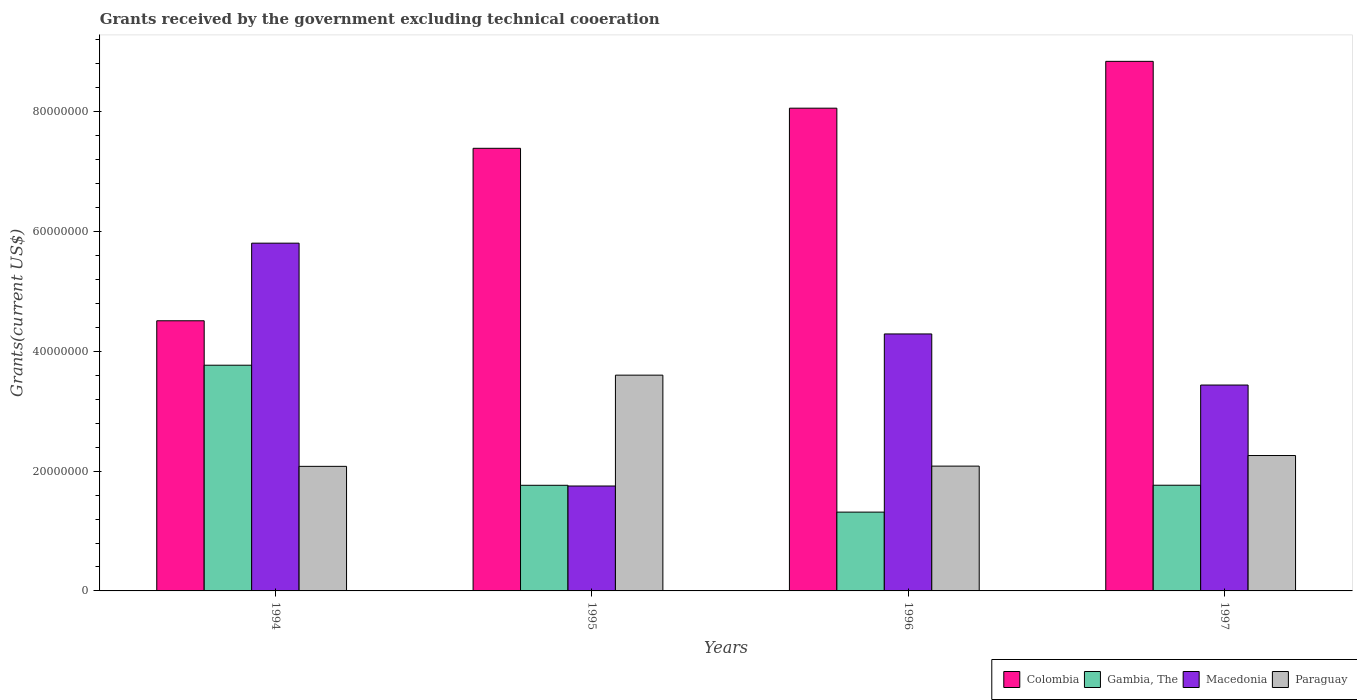How many groups of bars are there?
Give a very brief answer. 4. How many bars are there on the 2nd tick from the left?
Your answer should be very brief. 4. What is the label of the 2nd group of bars from the left?
Keep it short and to the point. 1995. In how many cases, is the number of bars for a given year not equal to the number of legend labels?
Your answer should be compact. 0. What is the total grants received by the government in Paraguay in 1994?
Offer a terse response. 2.08e+07. Across all years, what is the maximum total grants received by the government in Gambia, The?
Keep it short and to the point. 3.77e+07. Across all years, what is the minimum total grants received by the government in Gambia, The?
Give a very brief answer. 1.32e+07. In which year was the total grants received by the government in Colombia maximum?
Keep it short and to the point. 1997. What is the total total grants received by the government in Paraguay in the graph?
Offer a terse response. 1.00e+08. What is the difference between the total grants received by the government in Colombia in 1994 and that in 1996?
Your answer should be very brief. -3.55e+07. What is the difference between the total grants received by the government in Gambia, The in 1994 and the total grants received by the government in Paraguay in 1995?
Ensure brevity in your answer.  1.66e+06. What is the average total grants received by the government in Macedonia per year?
Give a very brief answer. 3.82e+07. In the year 1994, what is the difference between the total grants received by the government in Colombia and total grants received by the government in Macedonia?
Offer a very short reply. -1.30e+07. What is the ratio of the total grants received by the government in Paraguay in 1995 to that in 1996?
Keep it short and to the point. 1.73. Is the difference between the total grants received by the government in Colombia in 1995 and 1996 greater than the difference between the total grants received by the government in Macedonia in 1995 and 1996?
Give a very brief answer. Yes. What is the difference between the highest and the second highest total grants received by the government in Paraguay?
Your response must be concise. 1.34e+07. What is the difference between the highest and the lowest total grants received by the government in Colombia?
Your answer should be compact. 4.33e+07. In how many years, is the total grants received by the government in Colombia greater than the average total grants received by the government in Colombia taken over all years?
Offer a terse response. 3. What does the 3rd bar from the left in 1994 represents?
Your answer should be compact. Macedonia. What does the 4th bar from the right in 1995 represents?
Ensure brevity in your answer.  Colombia. How many years are there in the graph?
Ensure brevity in your answer.  4. Does the graph contain any zero values?
Provide a short and direct response. No. Where does the legend appear in the graph?
Make the answer very short. Bottom right. How many legend labels are there?
Offer a very short reply. 4. What is the title of the graph?
Your answer should be compact. Grants received by the government excluding technical cooeration. Does "Middle income" appear as one of the legend labels in the graph?
Keep it short and to the point. No. What is the label or title of the Y-axis?
Offer a terse response. Grants(current US$). What is the Grants(current US$) of Colombia in 1994?
Provide a short and direct response. 4.51e+07. What is the Grants(current US$) of Gambia, The in 1994?
Your answer should be very brief. 3.77e+07. What is the Grants(current US$) of Macedonia in 1994?
Offer a terse response. 5.81e+07. What is the Grants(current US$) in Paraguay in 1994?
Make the answer very short. 2.08e+07. What is the Grants(current US$) in Colombia in 1995?
Offer a very short reply. 7.39e+07. What is the Grants(current US$) of Gambia, The in 1995?
Ensure brevity in your answer.  1.76e+07. What is the Grants(current US$) in Macedonia in 1995?
Make the answer very short. 1.75e+07. What is the Grants(current US$) in Paraguay in 1995?
Give a very brief answer. 3.60e+07. What is the Grants(current US$) of Colombia in 1996?
Offer a terse response. 8.06e+07. What is the Grants(current US$) in Gambia, The in 1996?
Provide a succinct answer. 1.32e+07. What is the Grants(current US$) in Macedonia in 1996?
Offer a terse response. 4.29e+07. What is the Grants(current US$) in Paraguay in 1996?
Ensure brevity in your answer.  2.08e+07. What is the Grants(current US$) in Colombia in 1997?
Ensure brevity in your answer.  8.84e+07. What is the Grants(current US$) of Gambia, The in 1997?
Offer a very short reply. 1.76e+07. What is the Grants(current US$) of Macedonia in 1997?
Keep it short and to the point. 3.44e+07. What is the Grants(current US$) in Paraguay in 1997?
Keep it short and to the point. 2.26e+07. Across all years, what is the maximum Grants(current US$) of Colombia?
Give a very brief answer. 8.84e+07. Across all years, what is the maximum Grants(current US$) in Gambia, The?
Your answer should be very brief. 3.77e+07. Across all years, what is the maximum Grants(current US$) in Macedonia?
Offer a very short reply. 5.81e+07. Across all years, what is the maximum Grants(current US$) of Paraguay?
Provide a succinct answer. 3.60e+07. Across all years, what is the minimum Grants(current US$) of Colombia?
Provide a short and direct response. 4.51e+07. Across all years, what is the minimum Grants(current US$) of Gambia, The?
Make the answer very short. 1.32e+07. Across all years, what is the minimum Grants(current US$) of Macedonia?
Provide a succinct answer. 1.75e+07. Across all years, what is the minimum Grants(current US$) of Paraguay?
Make the answer very short. 2.08e+07. What is the total Grants(current US$) of Colombia in the graph?
Make the answer very short. 2.88e+08. What is the total Grants(current US$) in Gambia, The in the graph?
Offer a terse response. 8.61e+07. What is the total Grants(current US$) of Macedonia in the graph?
Give a very brief answer. 1.53e+08. What is the total Grants(current US$) of Paraguay in the graph?
Provide a succinct answer. 1.00e+08. What is the difference between the Grants(current US$) of Colombia in 1994 and that in 1995?
Provide a short and direct response. -2.88e+07. What is the difference between the Grants(current US$) in Gambia, The in 1994 and that in 1995?
Ensure brevity in your answer.  2.00e+07. What is the difference between the Grants(current US$) in Macedonia in 1994 and that in 1995?
Provide a short and direct response. 4.06e+07. What is the difference between the Grants(current US$) in Paraguay in 1994 and that in 1995?
Provide a succinct answer. -1.52e+07. What is the difference between the Grants(current US$) of Colombia in 1994 and that in 1996?
Your answer should be very brief. -3.55e+07. What is the difference between the Grants(current US$) in Gambia, The in 1994 and that in 1996?
Keep it short and to the point. 2.45e+07. What is the difference between the Grants(current US$) of Macedonia in 1994 and that in 1996?
Make the answer very short. 1.52e+07. What is the difference between the Grants(current US$) in Paraguay in 1994 and that in 1996?
Ensure brevity in your answer.  -4.00e+04. What is the difference between the Grants(current US$) of Colombia in 1994 and that in 1997?
Give a very brief answer. -4.33e+07. What is the difference between the Grants(current US$) in Gambia, The in 1994 and that in 1997?
Your answer should be very brief. 2.00e+07. What is the difference between the Grants(current US$) of Macedonia in 1994 and that in 1997?
Provide a succinct answer. 2.37e+07. What is the difference between the Grants(current US$) in Paraguay in 1994 and that in 1997?
Your answer should be very brief. -1.81e+06. What is the difference between the Grants(current US$) in Colombia in 1995 and that in 1996?
Keep it short and to the point. -6.70e+06. What is the difference between the Grants(current US$) in Gambia, The in 1995 and that in 1996?
Your answer should be compact. 4.48e+06. What is the difference between the Grants(current US$) of Macedonia in 1995 and that in 1996?
Your answer should be very brief. -2.54e+07. What is the difference between the Grants(current US$) in Paraguay in 1995 and that in 1996?
Offer a terse response. 1.52e+07. What is the difference between the Grants(current US$) in Colombia in 1995 and that in 1997?
Offer a very short reply. -1.45e+07. What is the difference between the Grants(current US$) in Macedonia in 1995 and that in 1997?
Give a very brief answer. -1.69e+07. What is the difference between the Grants(current US$) in Paraguay in 1995 and that in 1997?
Your response must be concise. 1.34e+07. What is the difference between the Grants(current US$) of Colombia in 1996 and that in 1997?
Make the answer very short. -7.82e+06. What is the difference between the Grants(current US$) of Gambia, The in 1996 and that in 1997?
Offer a very short reply. -4.49e+06. What is the difference between the Grants(current US$) of Macedonia in 1996 and that in 1997?
Keep it short and to the point. 8.53e+06. What is the difference between the Grants(current US$) in Paraguay in 1996 and that in 1997?
Your response must be concise. -1.77e+06. What is the difference between the Grants(current US$) in Colombia in 1994 and the Grants(current US$) in Gambia, The in 1995?
Offer a very short reply. 2.75e+07. What is the difference between the Grants(current US$) of Colombia in 1994 and the Grants(current US$) of Macedonia in 1995?
Your response must be concise. 2.76e+07. What is the difference between the Grants(current US$) of Colombia in 1994 and the Grants(current US$) of Paraguay in 1995?
Provide a succinct answer. 9.08e+06. What is the difference between the Grants(current US$) of Gambia, The in 1994 and the Grants(current US$) of Macedonia in 1995?
Give a very brief answer. 2.02e+07. What is the difference between the Grants(current US$) of Gambia, The in 1994 and the Grants(current US$) of Paraguay in 1995?
Make the answer very short. 1.66e+06. What is the difference between the Grants(current US$) of Macedonia in 1994 and the Grants(current US$) of Paraguay in 1995?
Make the answer very short. 2.20e+07. What is the difference between the Grants(current US$) in Colombia in 1994 and the Grants(current US$) in Gambia, The in 1996?
Provide a succinct answer. 3.20e+07. What is the difference between the Grants(current US$) in Colombia in 1994 and the Grants(current US$) in Macedonia in 1996?
Keep it short and to the point. 2.20e+06. What is the difference between the Grants(current US$) in Colombia in 1994 and the Grants(current US$) in Paraguay in 1996?
Your answer should be compact. 2.43e+07. What is the difference between the Grants(current US$) in Gambia, The in 1994 and the Grants(current US$) in Macedonia in 1996?
Your answer should be compact. -5.22e+06. What is the difference between the Grants(current US$) of Gambia, The in 1994 and the Grants(current US$) of Paraguay in 1996?
Make the answer very short. 1.68e+07. What is the difference between the Grants(current US$) of Macedonia in 1994 and the Grants(current US$) of Paraguay in 1996?
Make the answer very short. 3.72e+07. What is the difference between the Grants(current US$) of Colombia in 1994 and the Grants(current US$) of Gambia, The in 1997?
Provide a succinct answer. 2.75e+07. What is the difference between the Grants(current US$) of Colombia in 1994 and the Grants(current US$) of Macedonia in 1997?
Your answer should be compact. 1.07e+07. What is the difference between the Grants(current US$) of Colombia in 1994 and the Grants(current US$) of Paraguay in 1997?
Provide a short and direct response. 2.25e+07. What is the difference between the Grants(current US$) of Gambia, The in 1994 and the Grants(current US$) of Macedonia in 1997?
Give a very brief answer. 3.31e+06. What is the difference between the Grants(current US$) of Gambia, The in 1994 and the Grants(current US$) of Paraguay in 1997?
Give a very brief answer. 1.51e+07. What is the difference between the Grants(current US$) of Macedonia in 1994 and the Grants(current US$) of Paraguay in 1997?
Make the answer very short. 3.55e+07. What is the difference between the Grants(current US$) of Colombia in 1995 and the Grants(current US$) of Gambia, The in 1996?
Give a very brief answer. 6.08e+07. What is the difference between the Grants(current US$) in Colombia in 1995 and the Grants(current US$) in Macedonia in 1996?
Your answer should be compact. 3.10e+07. What is the difference between the Grants(current US$) of Colombia in 1995 and the Grants(current US$) of Paraguay in 1996?
Offer a terse response. 5.31e+07. What is the difference between the Grants(current US$) in Gambia, The in 1995 and the Grants(current US$) in Macedonia in 1996?
Keep it short and to the point. -2.53e+07. What is the difference between the Grants(current US$) of Gambia, The in 1995 and the Grants(current US$) of Paraguay in 1996?
Your response must be concise. -3.20e+06. What is the difference between the Grants(current US$) of Macedonia in 1995 and the Grants(current US$) of Paraguay in 1996?
Your answer should be very brief. -3.32e+06. What is the difference between the Grants(current US$) of Colombia in 1995 and the Grants(current US$) of Gambia, The in 1997?
Your answer should be compact. 5.63e+07. What is the difference between the Grants(current US$) of Colombia in 1995 and the Grants(current US$) of Macedonia in 1997?
Offer a terse response. 3.95e+07. What is the difference between the Grants(current US$) of Colombia in 1995 and the Grants(current US$) of Paraguay in 1997?
Ensure brevity in your answer.  5.13e+07. What is the difference between the Grants(current US$) in Gambia, The in 1995 and the Grants(current US$) in Macedonia in 1997?
Your answer should be compact. -1.67e+07. What is the difference between the Grants(current US$) in Gambia, The in 1995 and the Grants(current US$) in Paraguay in 1997?
Offer a very short reply. -4.97e+06. What is the difference between the Grants(current US$) of Macedonia in 1995 and the Grants(current US$) of Paraguay in 1997?
Your answer should be very brief. -5.09e+06. What is the difference between the Grants(current US$) of Colombia in 1996 and the Grants(current US$) of Gambia, The in 1997?
Your answer should be very brief. 6.30e+07. What is the difference between the Grants(current US$) of Colombia in 1996 and the Grants(current US$) of Macedonia in 1997?
Ensure brevity in your answer.  4.62e+07. What is the difference between the Grants(current US$) in Colombia in 1996 and the Grants(current US$) in Paraguay in 1997?
Give a very brief answer. 5.80e+07. What is the difference between the Grants(current US$) in Gambia, The in 1996 and the Grants(current US$) in Macedonia in 1997?
Offer a terse response. -2.12e+07. What is the difference between the Grants(current US$) in Gambia, The in 1996 and the Grants(current US$) in Paraguay in 1997?
Your response must be concise. -9.45e+06. What is the difference between the Grants(current US$) in Macedonia in 1996 and the Grants(current US$) in Paraguay in 1997?
Make the answer very short. 2.03e+07. What is the average Grants(current US$) in Colombia per year?
Keep it short and to the point. 7.20e+07. What is the average Grants(current US$) of Gambia, The per year?
Provide a succinct answer. 2.15e+07. What is the average Grants(current US$) in Macedonia per year?
Your response must be concise. 3.82e+07. What is the average Grants(current US$) in Paraguay per year?
Ensure brevity in your answer.  2.51e+07. In the year 1994, what is the difference between the Grants(current US$) in Colombia and Grants(current US$) in Gambia, The?
Your answer should be compact. 7.42e+06. In the year 1994, what is the difference between the Grants(current US$) in Colombia and Grants(current US$) in Macedonia?
Your answer should be very brief. -1.30e+07. In the year 1994, what is the difference between the Grants(current US$) in Colombia and Grants(current US$) in Paraguay?
Offer a very short reply. 2.43e+07. In the year 1994, what is the difference between the Grants(current US$) in Gambia, The and Grants(current US$) in Macedonia?
Offer a terse response. -2.04e+07. In the year 1994, what is the difference between the Grants(current US$) in Gambia, The and Grants(current US$) in Paraguay?
Your answer should be compact. 1.69e+07. In the year 1994, what is the difference between the Grants(current US$) of Macedonia and Grants(current US$) of Paraguay?
Your response must be concise. 3.73e+07. In the year 1995, what is the difference between the Grants(current US$) in Colombia and Grants(current US$) in Gambia, The?
Offer a terse response. 5.63e+07. In the year 1995, what is the difference between the Grants(current US$) of Colombia and Grants(current US$) of Macedonia?
Your answer should be compact. 5.64e+07. In the year 1995, what is the difference between the Grants(current US$) in Colombia and Grants(current US$) in Paraguay?
Give a very brief answer. 3.79e+07. In the year 1995, what is the difference between the Grants(current US$) in Gambia, The and Grants(current US$) in Paraguay?
Make the answer very short. -1.84e+07. In the year 1995, what is the difference between the Grants(current US$) of Macedonia and Grants(current US$) of Paraguay?
Your answer should be very brief. -1.85e+07. In the year 1996, what is the difference between the Grants(current US$) in Colombia and Grants(current US$) in Gambia, The?
Provide a succinct answer. 6.74e+07. In the year 1996, what is the difference between the Grants(current US$) of Colombia and Grants(current US$) of Macedonia?
Offer a terse response. 3.77e+07. In the year 1996, what is the difference between the Grants(current US$) in Colombia and Grants(current US$) in Paraguay?
Give a very brief answer. 5.98e+07. In the year 1996, what is the difference between the Grants(current US$) in Gambia, The and Grants(current US$) in Macedonia?
Make the answer very short. -2.98e+07. In the year 1996, what is the difference between the Grants(current US$) in Gambia, The and Grants(current US$) in Paraguay?
Your answer should be very brief. -7.68e+06. In the year 1996, what is the difference between the Grants(current US$) in Macedonia and Grants(current US$) in Paraguay?
Make the answer very short. 2.21e+07. In the year 1997, what is the difference between the Grants(current US$) of Colombia and Grants(current US$) of Gambia, The?
Offer a very short reply. 7.08e+07. In the year 1997, what is the difference between the Grants(current US$) in Colombia and Grants(current US$) in Macedonia?
Provide a short and direct response. 5.40e+07. In the year 1997, what is the difference between the Grants(current US$) of Colombia and Grants(current US$) of Paraguay?
Provide a short and direct response. 6.58e+07. In the year 1997, what is the difference between the Grants(current US$) in Gambia, The and Grants(current US$) in Macedonia?
Your answer should be very brief. -1.67e+07. In the year 1997, what is the difference between the Grants(current US$) of Gambia, The and Grants(current US$) of Paraguay?
Provide a short and direct response. -4.96e+06. In the year 1997, what is the difference between the Grants(current US$) of Macedonia and Grants(current US$) of Paraguay?
Provide a short and direct response. 1.18e+07. What is the ratio of the Grants(current US$) in Colombia in 1994 to that in 1995?
Provide a succinct answer. 0.61. What is the ratio of the Grants(current US$) in Gambia, The in 1994 to that in 1995?
Keep it short and to the point. 2.14. What is the ratio of the Grants(current US$) in Macedonia in 1994 to that in 1995?
Your answer should be very brief. 3.31. What is the ratio of the Grants(current US$) of Paraguay in 1994 to that in 1995?
Offer a terse response. 0.58. What is the ratio of the Grants(current US$) in Colombia in 1994 to that in 1996?
Your answer should be compact. 0.56. What is the ratio of the Grants(current US$) of Gambia, The in 1994 to that in 1996?
Provide a short and direct response. 2.86. What is the ratio of the Grants(current US$) in Macedonia in 1994 to that in 1996?
Keep it short and to the point. 1.35. What is the ratio of the Grants(current US$) of Paraguay in 1994 to that in 1996?
Your answer should be very brief. 1. What is the ratio of the Grants(current US$) in Colombia in 1994 to that in 1997?
Your answer should be very brief. 0.51. What is the ratio of the Grants(current US$) of Gambia, The in 1994 to that in 1997?
Ensure brevity in your answer.  2.14. What is the ratio of the Grants(current US$) in Macedonia in 1994 to that in 1997?
Keep it short and to the point. 1.69. What is the ratio of the Grants(current US$) of Paraguay in 1994 to that in 1997?
Provide a succinct answer. 0.92. What is the ratio of the Grants(current US$) in Colombia in 1995 to that in 1996?
Give a very brief answer. 0.92. What is the ratio of the Grants(current US$) in Gambia, The in 1995 to that in 1996?
Offer a terse response. 1.34. What is the ratio of the Grants(current US$) of Macedonia in 1995 to that in 1996?
Your answer should be compact. 0.41. What is the ratio of the Grants(current US$) in Paraguay in 1995 to that in 1996?
Ensure brevity in your answer.  1.73. What is the ratio of the Grants(current US$) in Colombia in 1995 to that in 1997?
Ensure brevity in your answer.  0.84. What is the ratio of the Grants(current US$) in Macedonia in 1995 to that in 1997?
Offer a terse response. 0.51. What is the ratio of the Grants(current US$) in Paraguay in 1995 to that in 1997?
Your answer should be very brief. 1.59. What is the ratio of the Grants(current US$) in Colombia in 1996 to that in 1997?
Your response must be concise. 0.91. What is the ratio of the Grants(current US$) of Gambia, The in 1996 to that in 1997?
Your response must be concise. 0.75. What is the ratio of the Grants(current US$) of Macedonia in 1996 to that in 1997?
Your answer should be compact. 1.25. What is the ratio of the Grants(current US$) in Paraguay in 1996 to that in 1997?
Make the answer very short. 0.92. What is the difference between the highest and the second highest Grants(current US$) in Colombia?
Keep it short and to the point. 7.82e+06. What is the difference between the highest and the second highest Grants(current US$) of Gambia, The?
Keep it short and to the point. 2.00e+07. What is the difference between the highest and the second highest Grants(current US$) of Macedonia?
Your response must be concise. 1.52e+07. What is the difference between the highest and the second highest Grants(current US$) of Paraguay?
Provide a short and direct response. 1.34e+07. What is the difference between the highest and the lowest Grants(current US$) in Colombia?
Provide a succinct answer. 4.33e+07. What is the difference between the highest and the lowest Grants(current US$) in Gambia, The?
Keep it short and to the point. 2.45e+07. What is the difference between the highest and the lowest Grants(current US$) of Macedonia?
Make the answer very short. 4.06e+07. What is the difference between the highest and the lowest Grants(current US$) of Paraguay?
Make the answer very short. 1.52e+07. 